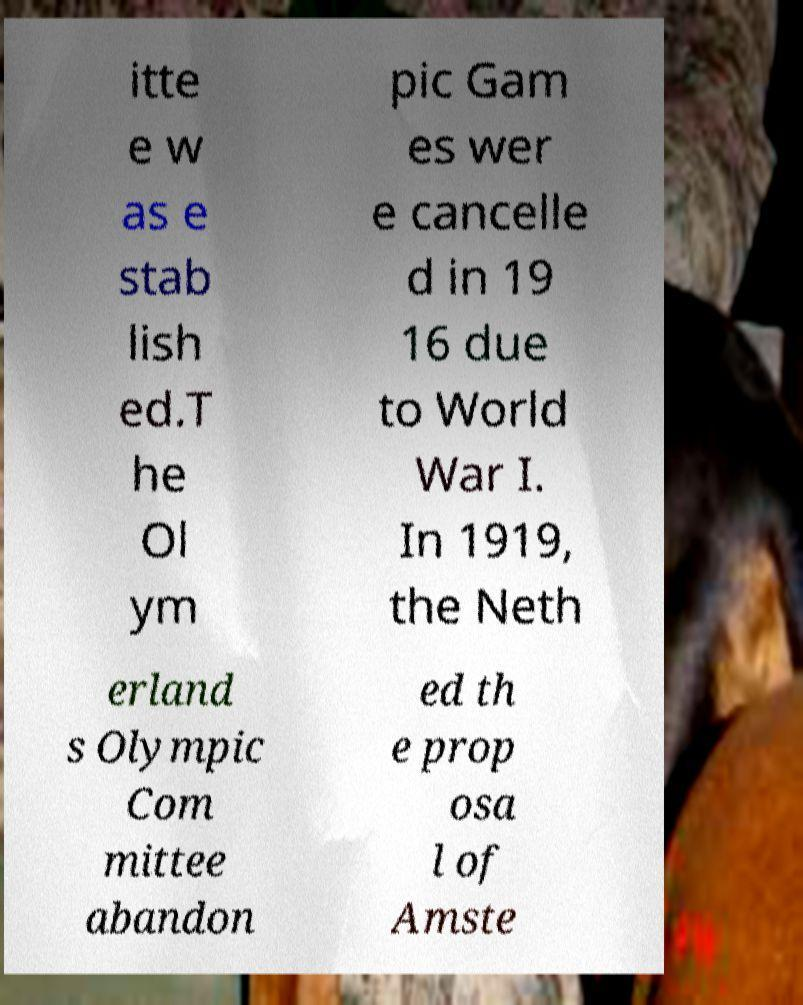For documentation purposes, I need the text within this image transcribed. Could you provide that? itte e w as e stab lish ed.T he Ol ym pic Gam es wer e cancelle d in 19 16 due to World War I. In 1919, the Neth erland s Olympic Com mittee abandon ed th e prop osa l of Amste 